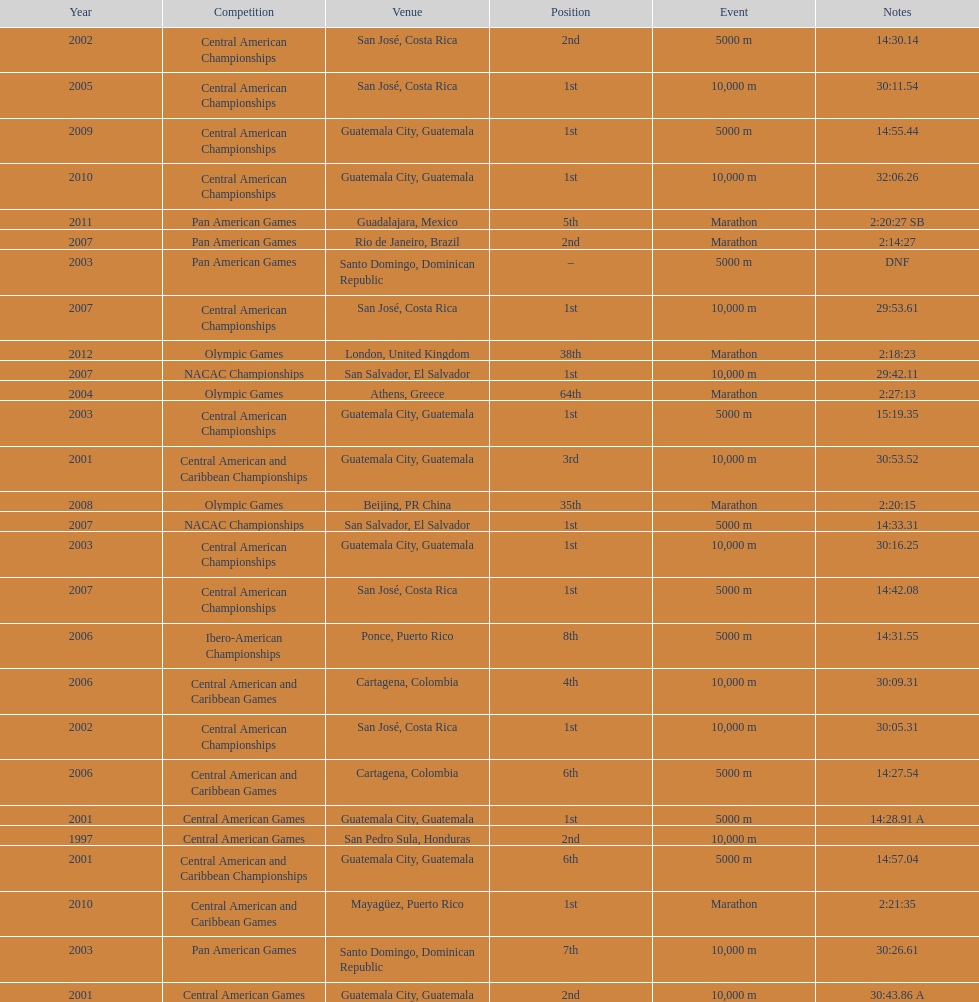What was the last competition in which a position of "2nd" was achieved? Pan American Games. 